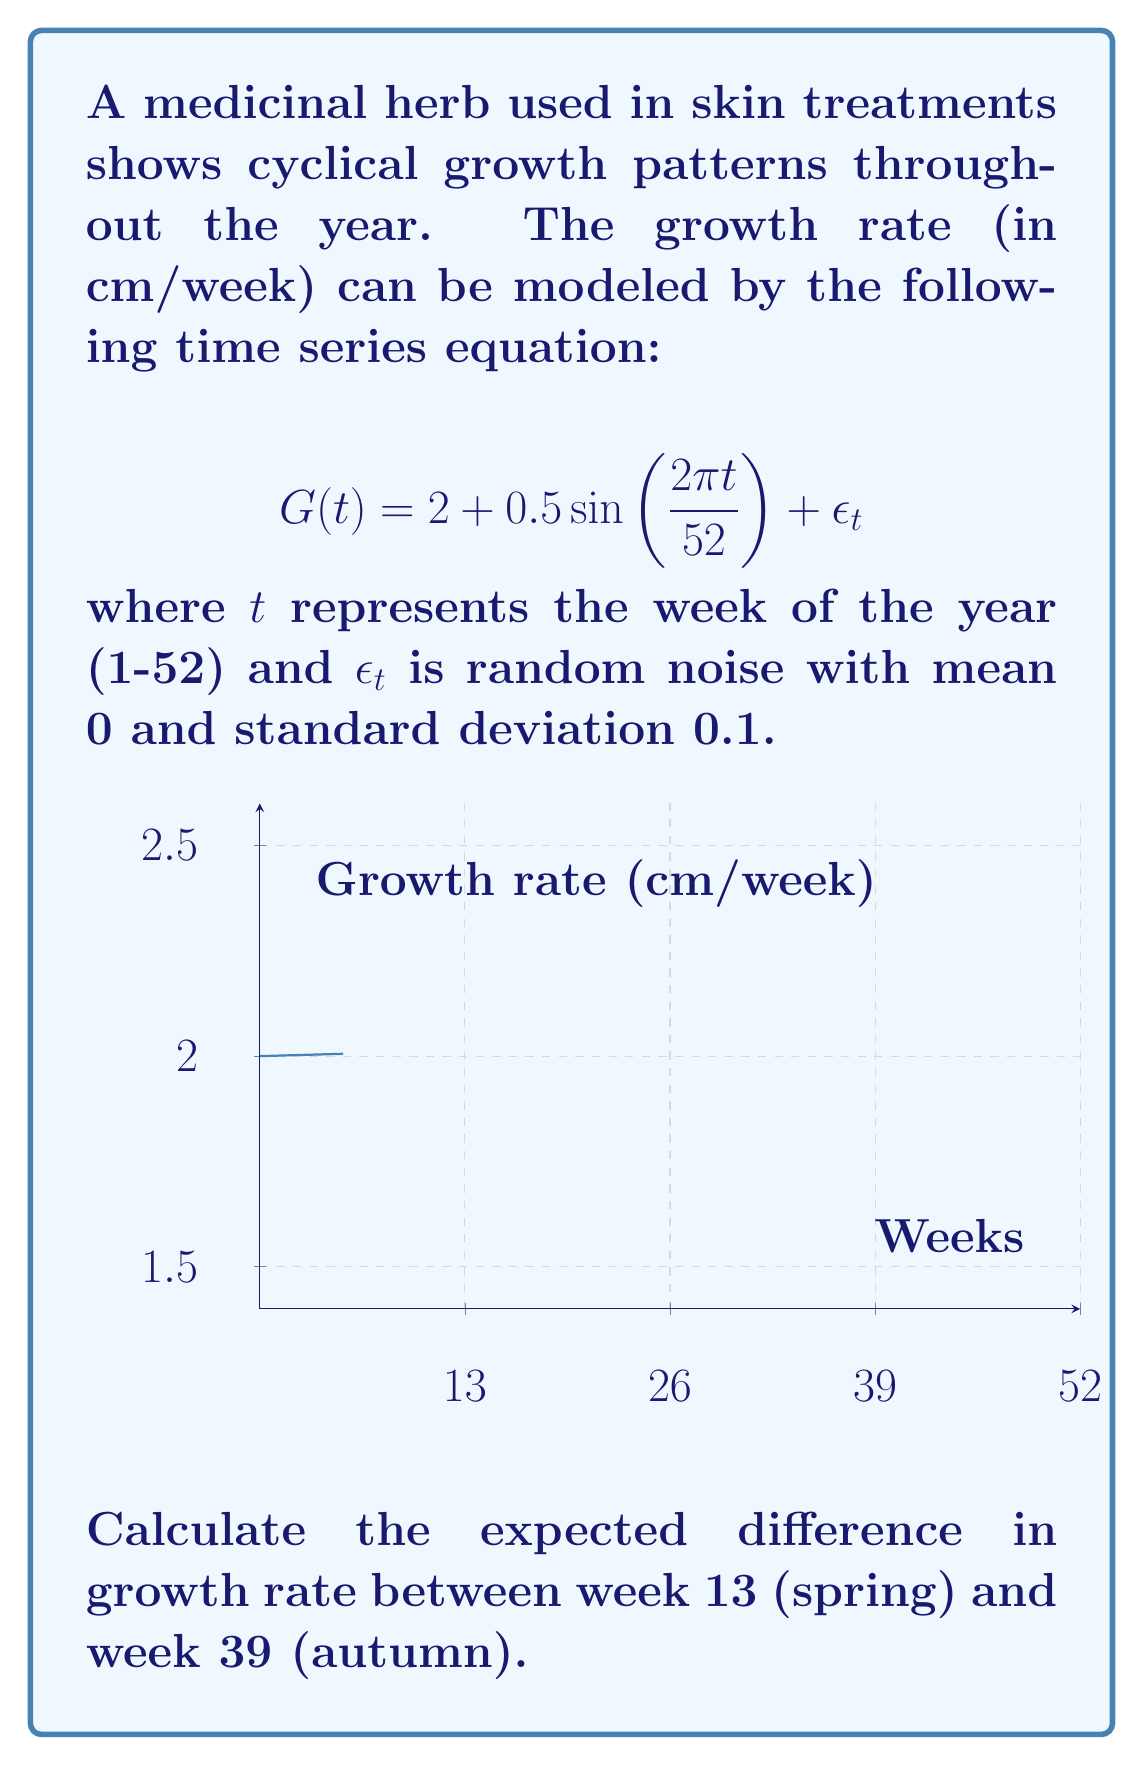Can you answer this question? To solve this problem, we need to follow these steps:

1) The growth rate function is given by:
   $$G(t) = 2 + 0.5 \sin(\frac{2\pi t}{52}) + \epsilon_t$$

2) We need to calculate the expected growth rates for weeks 13 and 39. The expected value eliminates the random noise term $\epsilon_t$ as its mean is 0.

3) For week 13 (spring):
   $$E[G(13)] = 2 + 0.5 \sin(\frac{2\pi \cdot 13}{52})$$
   $$= 2 + 0.5 \sin(1.5708)$$
   $$\approx 2 + 0.5 = 2.5 \text{ cm/week}$$

4) For week 39 (autumn):
   $$E[G(39)] = 2 + 0.5 \sin(\frac{2\pi \cdot 39}{52})$$
   $$= 2 + 0.5 \sin(4.7124)$$
   $$\approx 2 - 0.5 = 1.5 \text{ cm/week}$$

5) The difference in growth rate:
   $$\text{Difference} = E[G(13)] - E[G(39)]$$
   $$= 2.5 - 1.5 = 1 \text{ cm/week}$$
Answer: 1 cm/week 